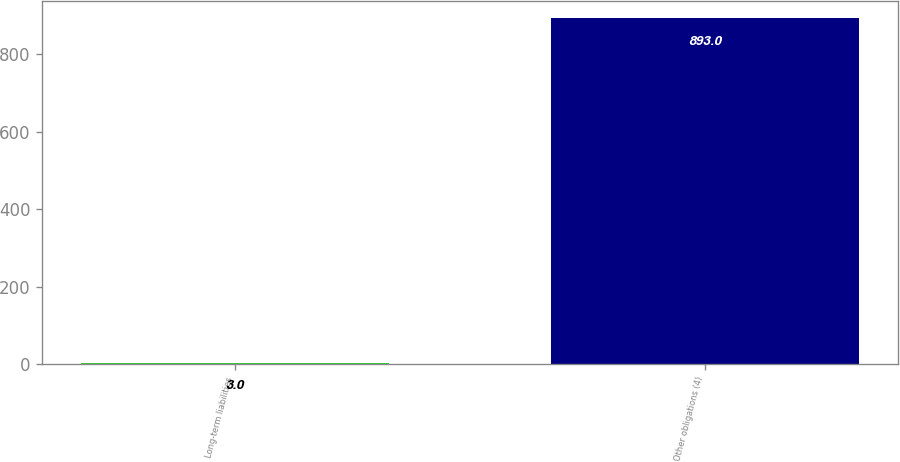<chart> <loc_0><loc_0><loc_500><loc_500><bar_chart><fcel>Long-term liabilities<fcel>Other obligations (4)<nl><fcel>3<fcel>893<nl></chart> 